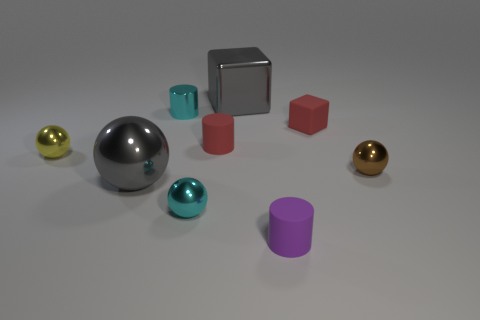What number of rubber things are red things or cyan cylinders? In the image, there is a total of one red cube which can be classified as a rubber thing, and one cyan cylinder. So, the correct number of rubber items that are either red or cyan cylinders is one, as the red cube counts as one rubber item and the cyan cylinder as one separate item. 